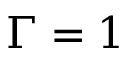Convert formula to latex. <formula><loc_0><loc_0><loc_500><loc_500>\Gamma = 1</formula> 